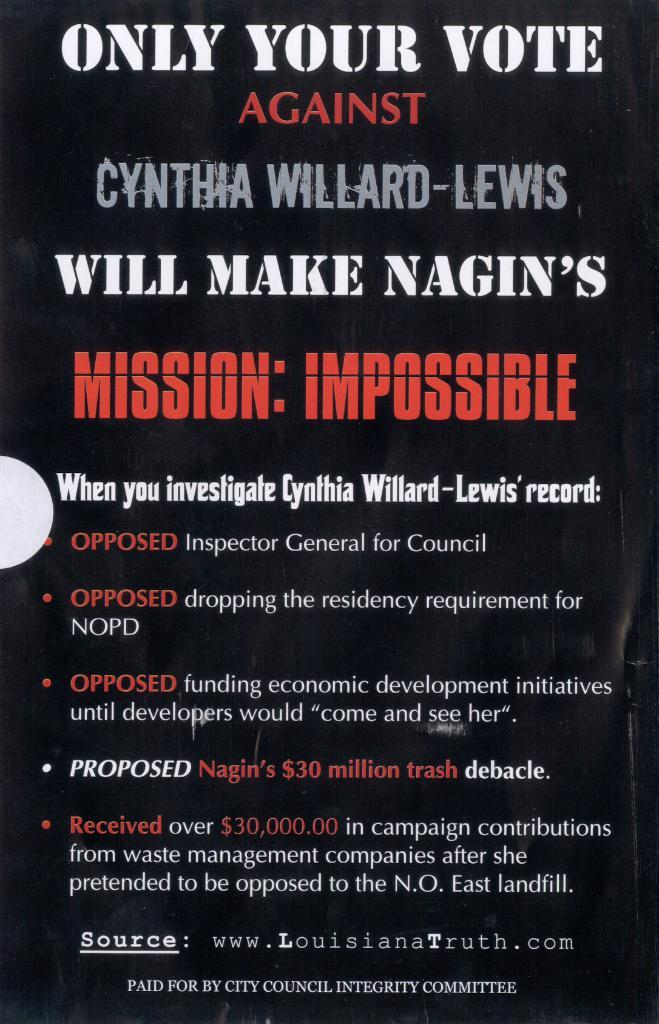<image>
Present a compact description of the photo's key features. A piece of political advertisement that asks you to vote against cynthia willard lewis. 